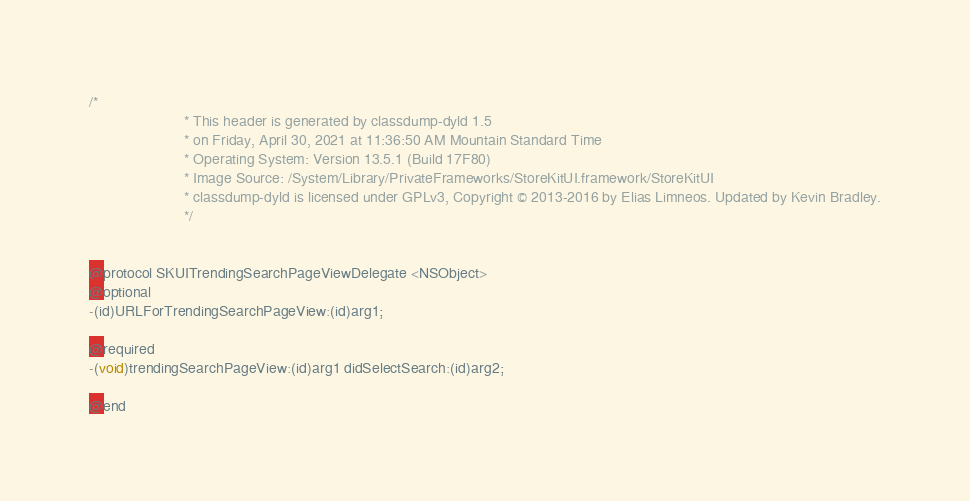Convert code to text. <code><loc_0><loc_0><loc_500><loc_500><_C_>/*
                       * This header is generated by classdump-dyld 1.5
                       * on Friday, April 30, 2021 at 11:36:50 AM Mountain Standard Time
                       * Operating System: Version 13.5.1 (Build 17F80)
                       * Image Source: /System/Library/PrivateFrameworks/StoreKitUI.framework/StoreKitUI
                       * classdump-dyld is licensed under GPLv3, Copyright © 2013-2016 by Elias Limneos. Updated by Kevin Bradley.
                       */


@protocol SKUITrendingSearchPageViewDelegate <NSObject>
@optional
-(id)URLForTrendingSearchPageView:(id)arg1;

@required
-(void)trendingSearchPageView:(id)arg1 didSelectSearch:(id)arg2;

@end

</code> 